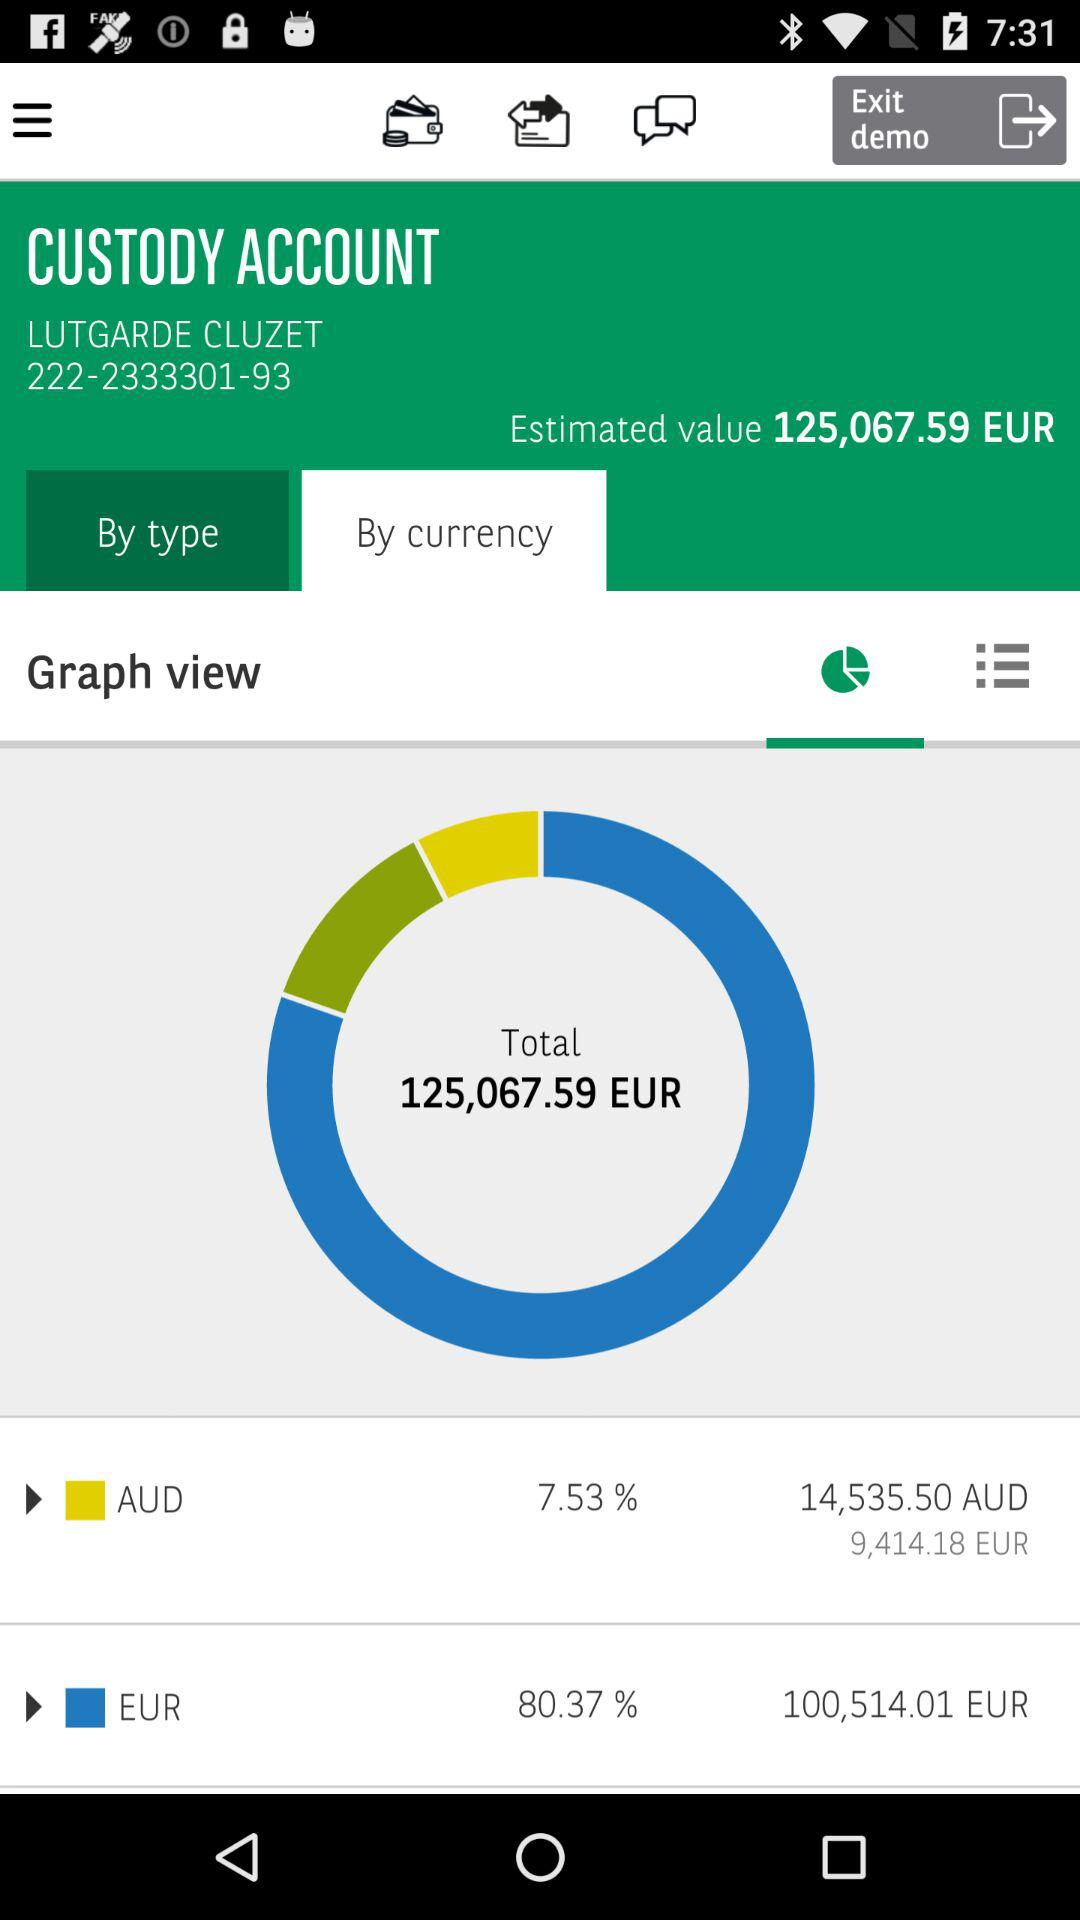What is the percentage mentioned for AUD? The mentioned percentage for AUD is 7.53. 